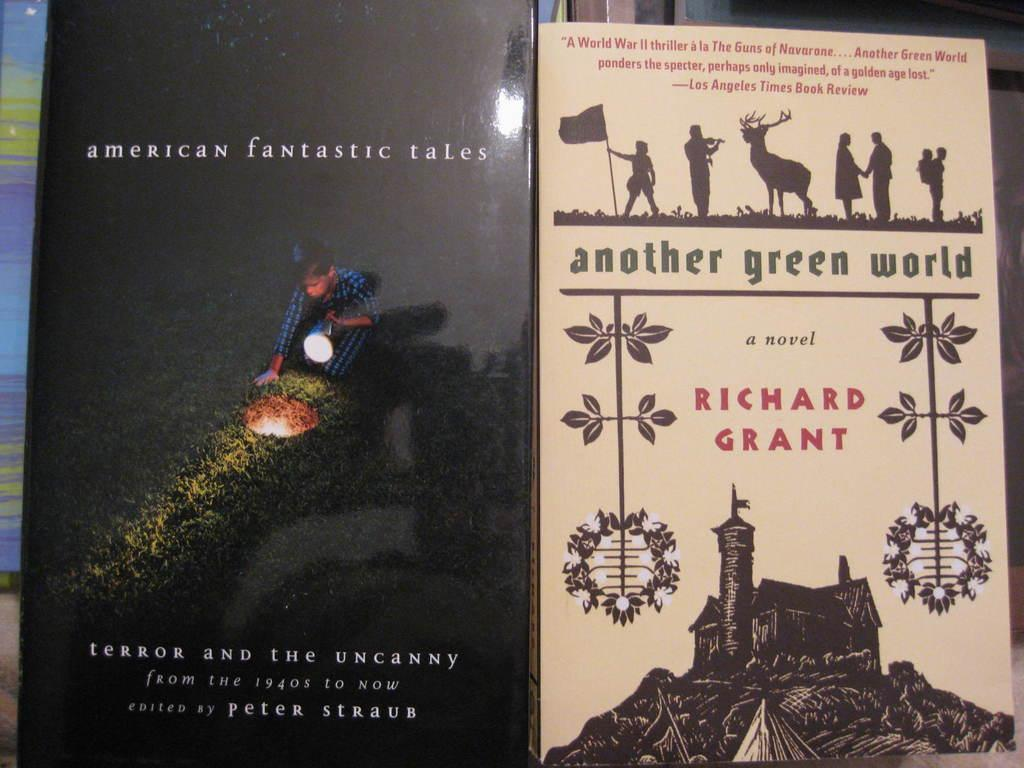<image>
Render a clear and concise summary of the photo. The book to the left advertises terror and the uncanny stories. 